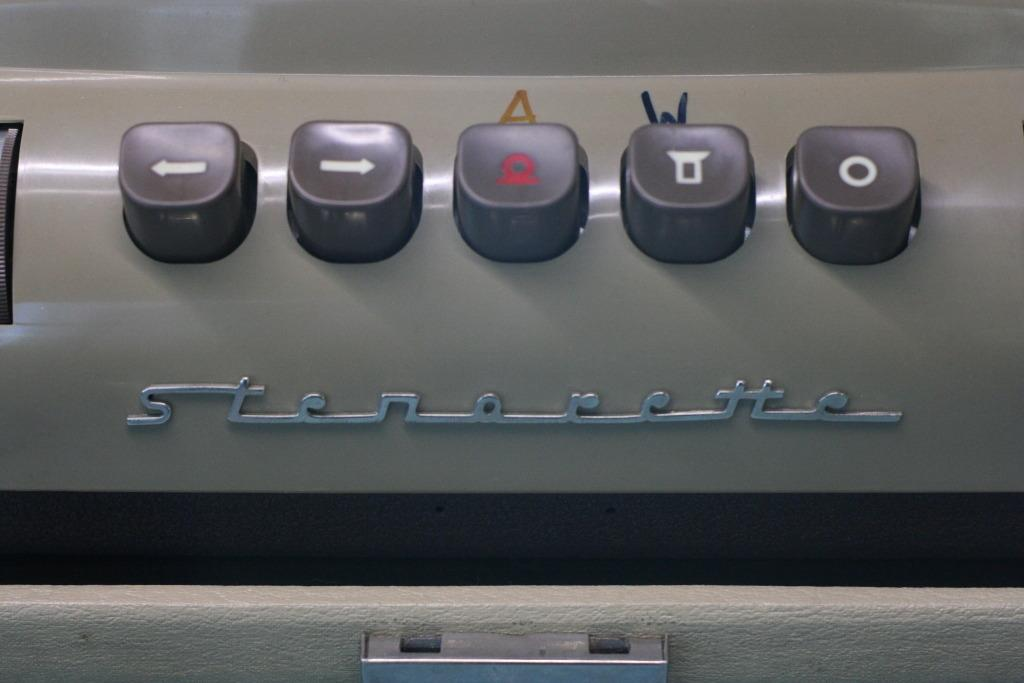<image>
Offer a succinct explanation of the picture presented. Control buttons with the word Stereorette under them. 